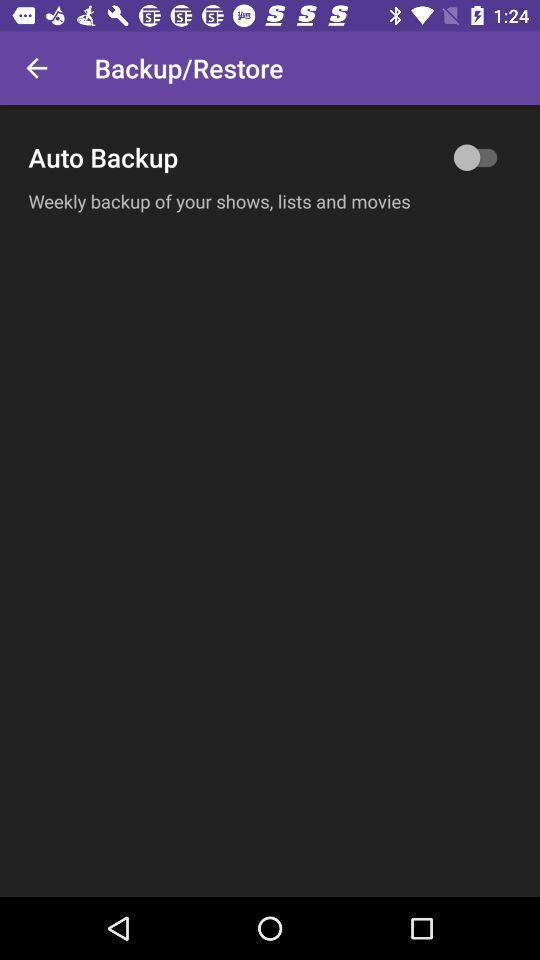Provide a description of this screenshot. Settings page of backup or restore. 